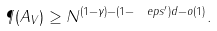<formula> <loc_0><loc_0><loc_500><loc_500>\P ( A _ { V } ) \geq N ^ { ( 1 - \gamma ) - ( 1 - \ e p s ^ { \prime } ) d - o ( 1 ) } .</formula> 